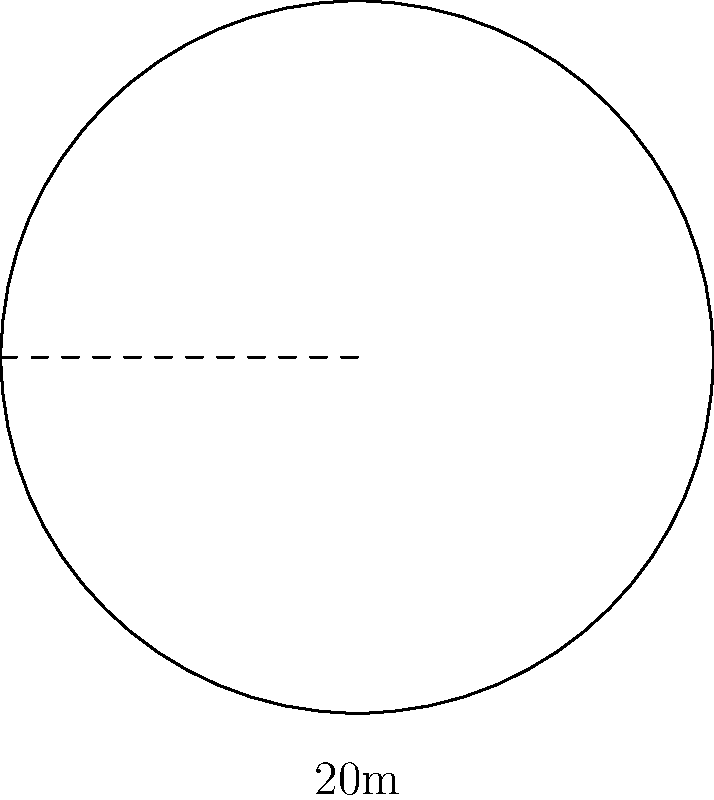A new cryptocurrency exchange is planning to build a circular trading floor. The architects have designed the floor with a radius of 20 meters. As a policy advisor, you need to estimate the total length of the security barrier required to encircle the trading floor. What is the approximate circumference of the circular trading floor in meters? To find the circumference of a circular trading floor, we can follow these steps:

1. Recall the formula for the circumference of a circle:
   $$C = 2\pi r$$
   where $C$ is the circumference and $r$ is the radius.

2. We are given that the radius is 20 meters.

3. Substitute the radius into the formula:
   $$C = 2\pi (20)$$

4. Simplify:
   $$C = 40\pi$$

5. To get an approximate value, we can use $\pi \approx 3.14159$:
   $$C \approx 40 * 3.14159 = 125.6636$$

6. Rounding to the nearest meter:
   $$C \approx 126 \text{ meters}$$

Therefore, the approximate circumference of the circular trading floor is 126 meters.
Answer: 126 meters 